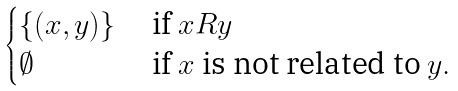<formula> <loc_0><loc_0><loc_500><loc_500>\begin{cases} \{ ( x , y ) \} & \text { if } x R y \\ \emptyset & \text { if } x \text { is not related to } y . \end{cases}</formula> 